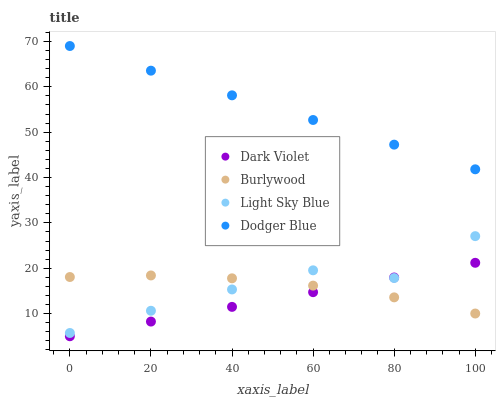Does Dark Violet have the minimum area under the curve?
Answer yes or no. Yes. Does Dodger Blue have the maximum area under the curve?
Answer yes or no. Yes. Does Light Sky Blue have the minimum area under the curve?
Answer yes or no. No. Does Light Sky Blue have the maximum area under the curve?
Answer yes or no. No. Is Dark Violet the smoothest?
Answer yes or no. Yes. Is Light Sky Blue the roughest?
Answer yes or no. Yes. Is Dodger Blue the smoothest?
Answer yes or no. No. Is Dodger Blue the roughest?
Answer yes or no. No. Does Dark Violet have the lowest value?
Answer yes or no. Yes. Does Light Sky Blue have the lowest value?
Answer yes or no. No. Does Dodger Blue have the highest value?
Answer yes or no. Yes. Does Light Sky Blue have the highest value?
Answer yes or no. No. Is Dark Violet less than Dodger Blue?
Answer yes or no. Yes. Is Dodger Blue greater than Burlywood?
Answer yes or no. Yes. Does Burlywood intersect Dark Violet?
Answer yes or no. Yes. Is Burlywood less than Dark Violet?
Answer yes or no. No. Is Burlywood greater than Dark Violet?
Answer yes or no. No. Does Dark Violet intersect Dodger Blue?
Answer yes or no. No. 